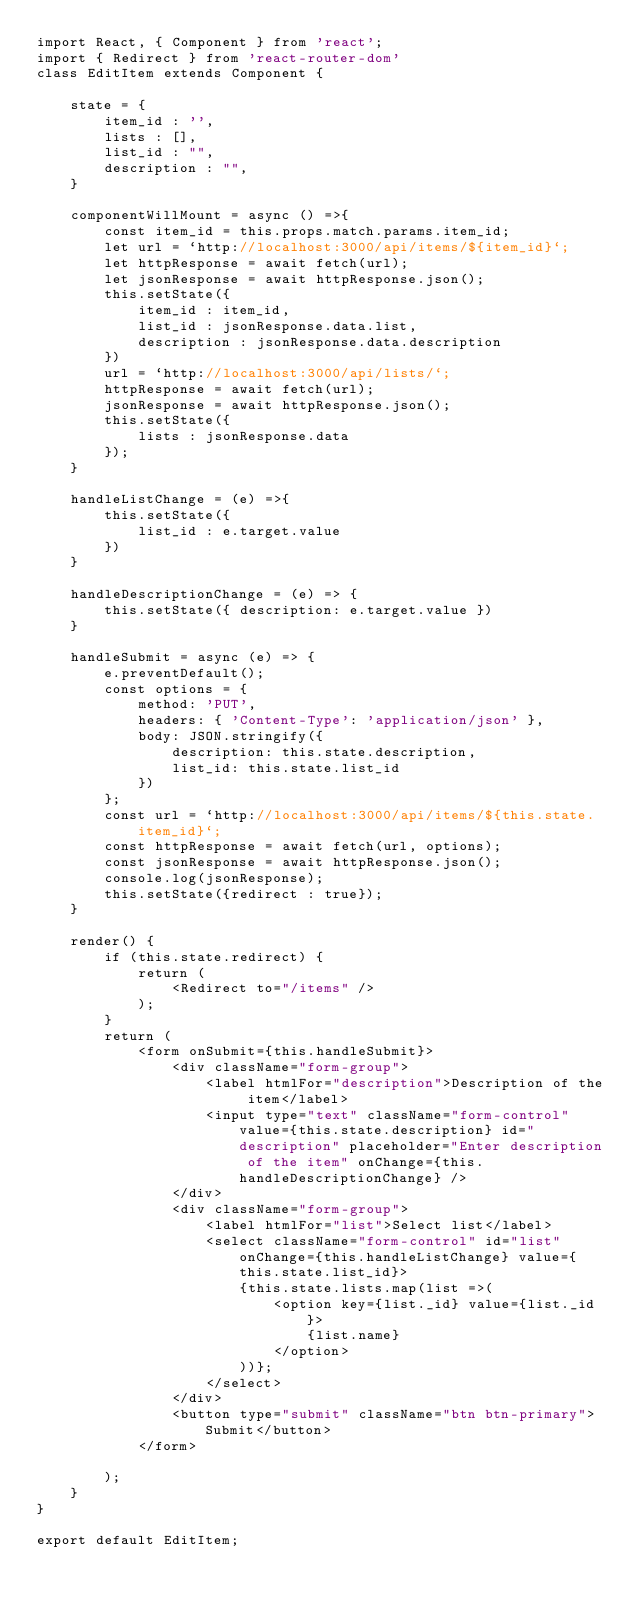<code> <loc_0><loc_0><loc_500><loc_500><_JavaScript_>import React, { Component } from 'react';
import { Redirect } from 'react-router-dom'
class EditItem extends Component {

    state = {
        item_id : '',
        lists : [],
        list_id : "",
        description : "",
    }

    componentWillMount = async () =>{
        const item_id = this.props.match.params.item_id;
        let url = `http://localhost:3000/api/items/${item_id}`;
        let httpResponse = await fetch(url);
        let jsonResponse = await httpResponse.json();
        this.setState({
            item_id : item_id,
            list_id : jsonResponse.data.list,
            description : jsonResponse.data.description
        })
        url = `http://localhost:3000/api/lists/`;
        httpResponse = await fetch(url);
        jsonResponse = await httpResponse.json();
        this.setState({
            lists : jsonResponse.data
        });
    }

    handleListChange = (e) =>{
        this.setState({
            list_id : e.target.value
        })
    }

    handleDescriptionChange = (e) => {
        this.setState({ description: e.target.value })
    }

    handleSubmit = async (e) => {
        e.preventDefault();
        const options = {
            method: 'PUT',
            headers: { 'Content-Type': 'application/json' },
            body: JSON.stringify({
                description: this.state.description,
                list_id: this.state.list_id
            })
        };
        const url = `http://localhost:3000/api/items/${this.state.item_id}`;
        const httpResponse = await fetch(url, options);
        const jsonResponse = await httpResponse.json();
        console.log(jsonResponse);
        this.setState({redirect : true});
    }

    render() {
        if (this.state.redirect) {
            return (
                <Redirect to="/items" />
            );
        }
        return (
            <form onSubmit={this.handleSubmit}>
                <div className="form-group">
                    <label htmlFor="description">Description of the item</label>
                    <input type="text" className="form-control" value={this.state.description} id="description" placeholder="Enter description of the item" onChange={this.handleDescriptionChange} />
                </div>
                <div className="form-group">
                    <label htmlFor="list">Select list</label>
                    <select className="form-control" id="list" onChange={this.handleListChange} value={this.state.list_id}>
                        {this.state.lists.map(list =>(
                            <option key={list._id} value={list._id}>
                                {list.name}
                            </option>
                        ))};
                    </select>
                </div>
                <button type="submit" className="btn btn-primary">Submit</button>
            </form>

        );
    }
}

export default EditItem;</code> 